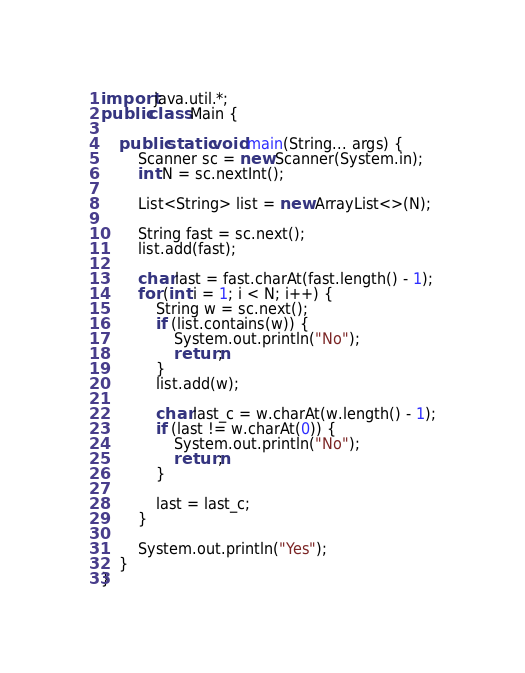Convert code to text. <code><loc_0><loc_0><loc_500><loc_500><_Java_>import java.util.*;
public class Main {
	
	public static void main(String... args) {
		Scanner sc = new Scanner(System.in);
		int N = sc.nextInt();
		
		List<String> list = new ArrayList<>(N);
		
		String fast = sc.next();
		list.add(fast);
		
		char last = fast.charAt(fast.length() - 1);
		for (int i = 1; i < N; i++) {
			String w = sc.next();
			if (list.contains(w)) {
				System.out.println("No");
				return;
			}
			list.add(w);
			
			char last_c = w.charAt(w.length() - 1);
			if (last != w.charAt(0)) {
				System.out.println("No");
				return;
			}
			
			last = last_c;
		}
		
		System.out.println("Yes");
	}
}</code> 